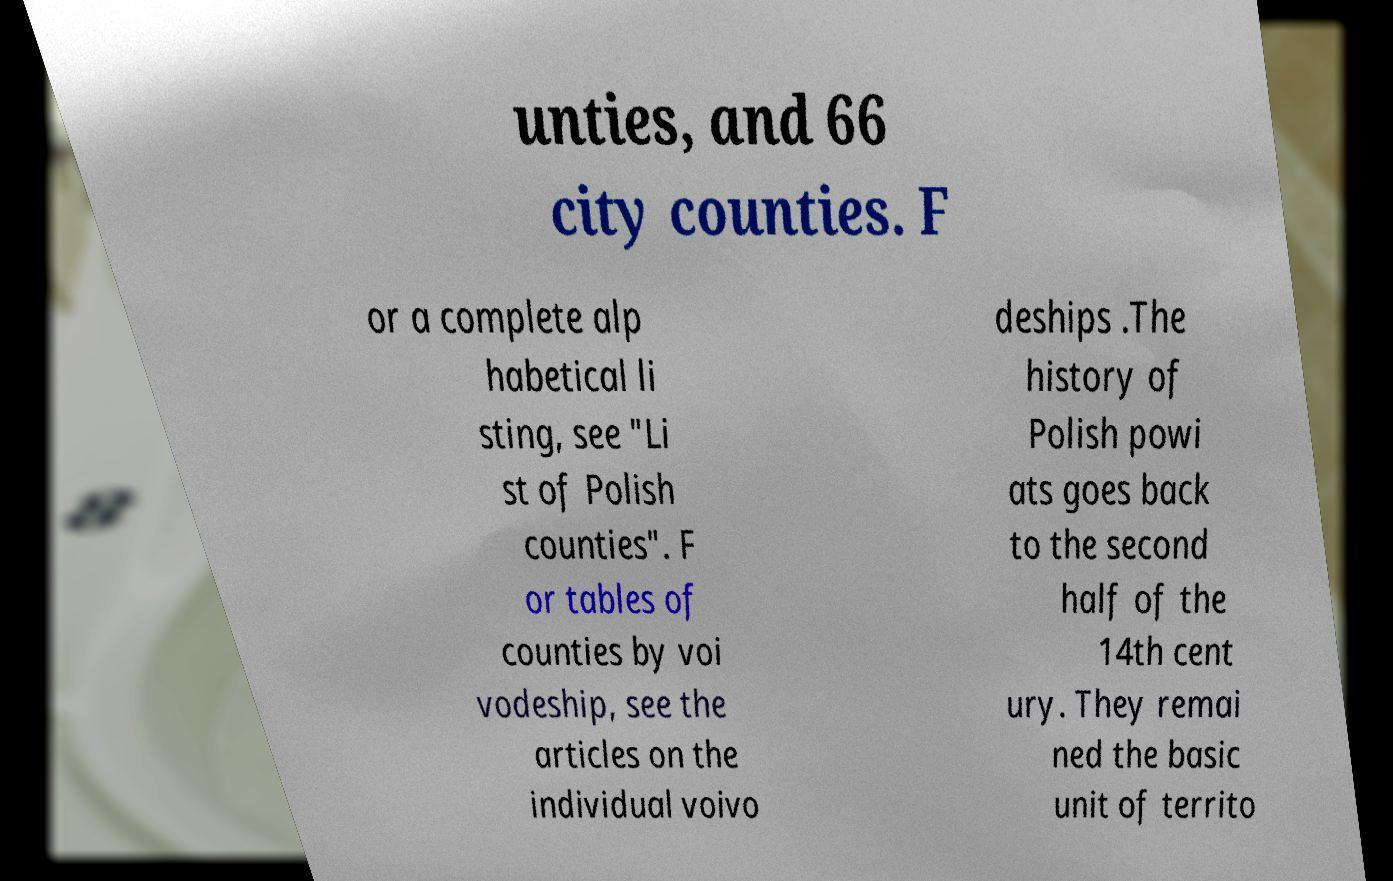Please identify and transcribe the text found in this image. unties, and 66 city counties. F or a complete alp habetical li sting, see "Li st of Polish counties". F or tables of counties by voi vodeship, see the articles on the individual voivo deships .The history of Polish powi ats goes back to the second half of the 14th cent ury. They remai ned the basic unit of territo 